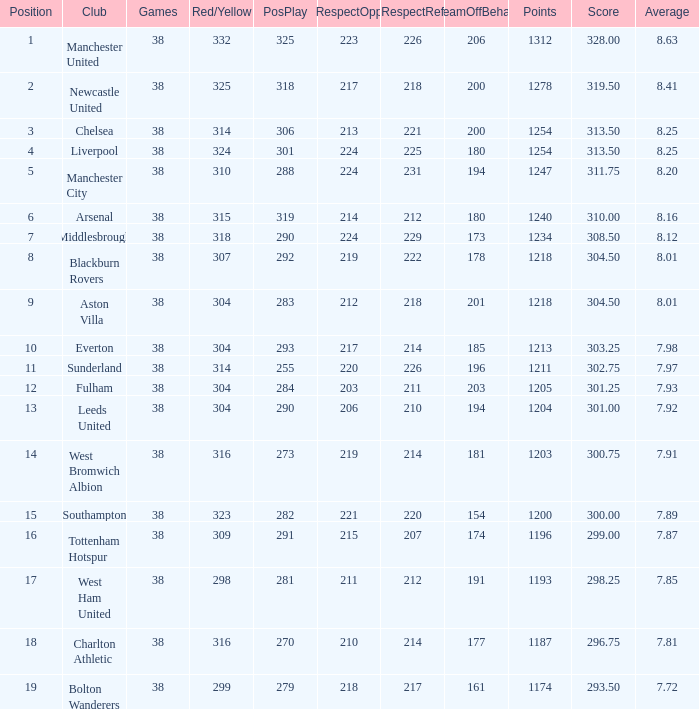Would you mind parsing the complete table? {'header': ['Position', 'Club', 'Games', 'Red/Yellow', 'PosPlay', 'RespectOpp', 'RespectRef', 'TeamOffBehav', 'Points', 'Score', 'Average'], 'rows': [['1', 'Manchester United', '38', '332', '325', '223', '226', '206', '1312', '328.00', '8.63'], ['2', 'Newcastle United', '38', '325', '318', '217', '218', '200', '1278', '319.50', '8.41'], ['3', 'Chelsea', '38', '314', '306', '213', '221', '200', '1254', '313.50', '8.25'], ['4', 'Liverpool', '38', '324', '301', '224', '225', '180', '1254', '313.50', '8.25'], ['5', 'Manchester City', '38', '310', '288', '224', '231', '194', '1247', '311.75', '8.20'], ['6', 'Arsenal', '38', '315', '319', '214', '212', '180', '1240', '310.00', '8.16'], ['7', 'Middlesbrough', '38', '318', '290', '224', '229', '173', '1234', '308.50', '8.12'], ['8', 'Blackburn Rovers', '38', '307', '292', '219', '222', '178', '1218', '304.50', '8.01'], ['9', 'Aston Villa', '38', '304', '283', '212', '218', '201', '1218', '304.50', '8.01'], ['10', 'Everton', '38', '304', '293', '217', '214', '185', '1213', '303.25', '7.98'], ['11', 'Sunderland', '38', '314', '255', '220', '226', '196', '1211', '302.75', '7.97'], ['12', 'Fulham', '38', '304', '284', '203', '211', '203', '1205', '301.25', '7.93'], ['13', 'Leeds United', '38', '304', '290', '206', '210', '194', '1204', '301.00', '7.92'], ['14', 'West Bromwich Albion', '38', '316', '273', '219', '214', '181', '1203', '300.75', '7.91'], ['15', 'Southampton', '38', '323', '282', '221', '220', '154', '1200', '300.00', '7.89'], ['16', 'Tottenham Hotspur', '38', '309', '291', '215', '207', '174', '1196', '299.00', '7.87'], ['17', 'West Ham United', '38', '298', '281', '211', '212', '191', '1193', '298.25', '7.85'], ['18', 'Charlton Athletic', '38', '316', '270', '210', '214', '177', '1187', '296.75', '7.81'], ['19', 'Bolton Wanderers', '38', '299', '279', '218', '217', '161', '1174', '293.50', '7.72']]} Determine the most advantageous element for west bromwich albion club. 14.0. 